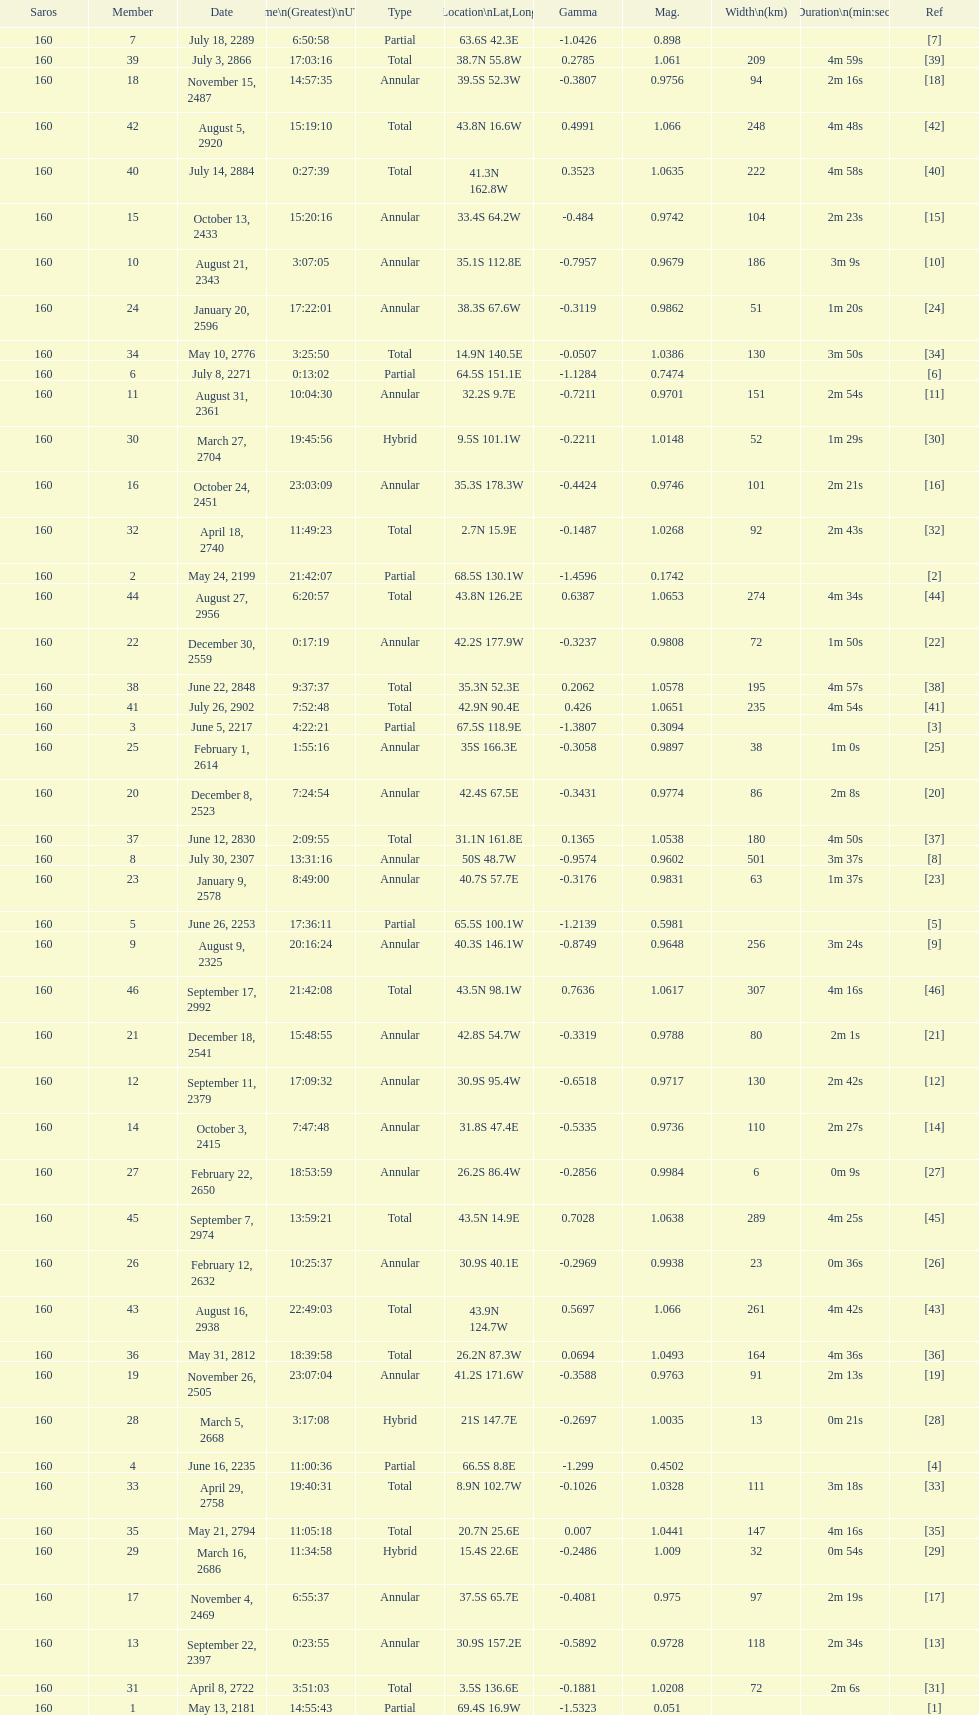When will the next solar saros be after the may 24, 2199 solar saros occurs? June 5, 2217. 